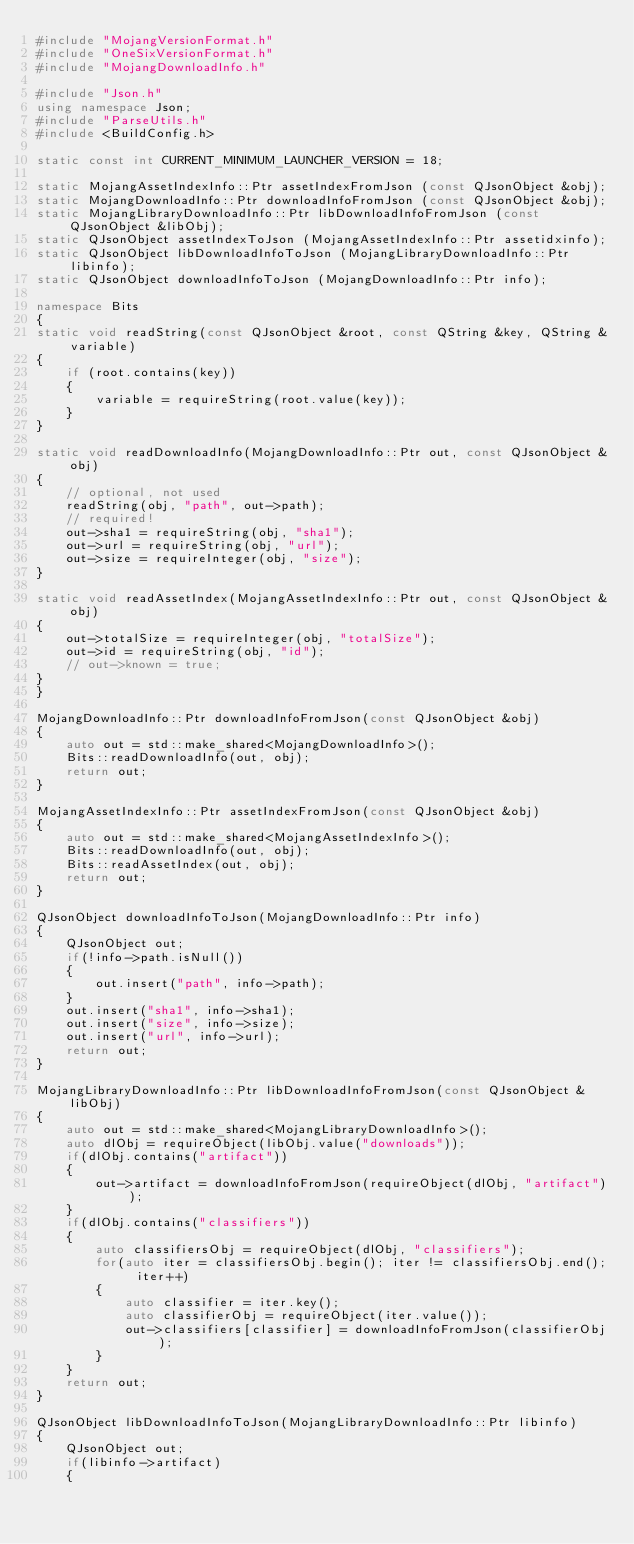Convert code to text. <code><loc_0><loc_0><loc_500><loc_500><_C++_>#include "MojangVersionFormat.h"
#include "OneSixVersionFormat.h"
#include "MojangDownloadInfo.h"

#include "Json.h"
using namespace Json;
#include "ParseUtils.h"
#include <BuildConfig.h>

static const int CURRENT_MINIMUM_LAUNCHER_VERSION = 18;

static MojangAssetIndexInfo::Ptr assetIndexFromJson (const QJsonObject &obj);
static MojangDownloadInfo::Ptr downloadInfoFromJson (const QJsonObject &obj);
static MojangLibraryDownloadInfo::Ptr libDownloadInfoFromJson (const QJsonObject &libObj);
static QJsonObject assetIndexToJson (MojangAssetIndexInfo::Ptr assetidxinfo);
static QJsonObject libDownloadInfoToJson (MojangLibraryDownloadInfo::Ptr libinfo);
static QJsonObject downloadInfoToJson (MojangDownloadInfo::Ptr info);

namespace Bits
{
static void readString(const QJsonObject &root, const QString &key, QString &variable)
{
    if (root.contains(key))
    {
        variable = requireString(root.value(key));
    }
}

static void readDownloadInfo(MojangDownloadInfo::Ptr out, const QJsonObject &obj)
{
    // optional, not used
    readString(obj, "path", out->path);
    // required!
    out->sha1 = requireString(obj, "sha1");
    out->url = requireString(obj, "url");
    out->size = requireInteger(obj, "size");
}

static void readAssetIndex(MojangAssetIndexInfo::Ptr out, const QJsonObject &obj)
{
    out->totalSize = requireInteger(obj, "totalSize");
    out->id = requireString(obj, "id");
    // out->known = true;
}
}

MojangDownloadInfo::Ptr downloadInfoFromJson(const QJsonObject &obj)
{
    auto out = std::make_shared<MojangDownloadInfo>();
    Bits::readDownloadInfo(out, obj);
    return out;
}

MojangAssetIndexInfo::Ptr assetIndexFromJson(const QJsonObject &obj)
{
    auto out = std::make_shared<MojangAssetIndexInfo>();
    Bits::readDownloadInfo(out, obj);
    Bits::readAssetIndex(out, obj);
    return out;
}

QJsonObject downloadInfoToJson(MojangDownloadInfo::Ptr info)
{
    QJsonObject out;
    if(!info->path.isNull())
    {
        out.insert("path", info->path);
    }
    out.insert("sha1", info->sha1);
    out.insert("size", info->size);
    out.insert("url", info->url);
    return out;
}

MojangLibraryDownloadInfo::Ptr libDownloadInfoFromJson(const QJsonObject &libObj)
{
    auto out = std::make_shared<MojangLibraryDownloadInfo>();
    auto dlObj = requireObject(libObj.value("downloads"));
    if(dlObj.contains("artifact"))
    {
        out->artifact = downloadInfoFromJson(requireObject(dlObj, "artifact"));
    }
    if(dlObj.contains("classifiers"))
    {
        auto classifiersObj = requireObject(dlObj, "classifiers");
        for(auto iter = classifiersObj.begin(); iter != classifiersObj.end(); iter++)
        {
            auto classifier = iter.key();
            auto classifierObj = requireObject(iter.value());
            out->classifiers[classifier] = downloadInfoFromJson(classifierObj);
        }
    }
    return out;
}

QJsonObject libDownloadInfoToJson(MojangLibraryDownloadInfo::Ptr libinfo)
{
    QJsonObject out;
    if(libinfo->artifact)
    {</code> 